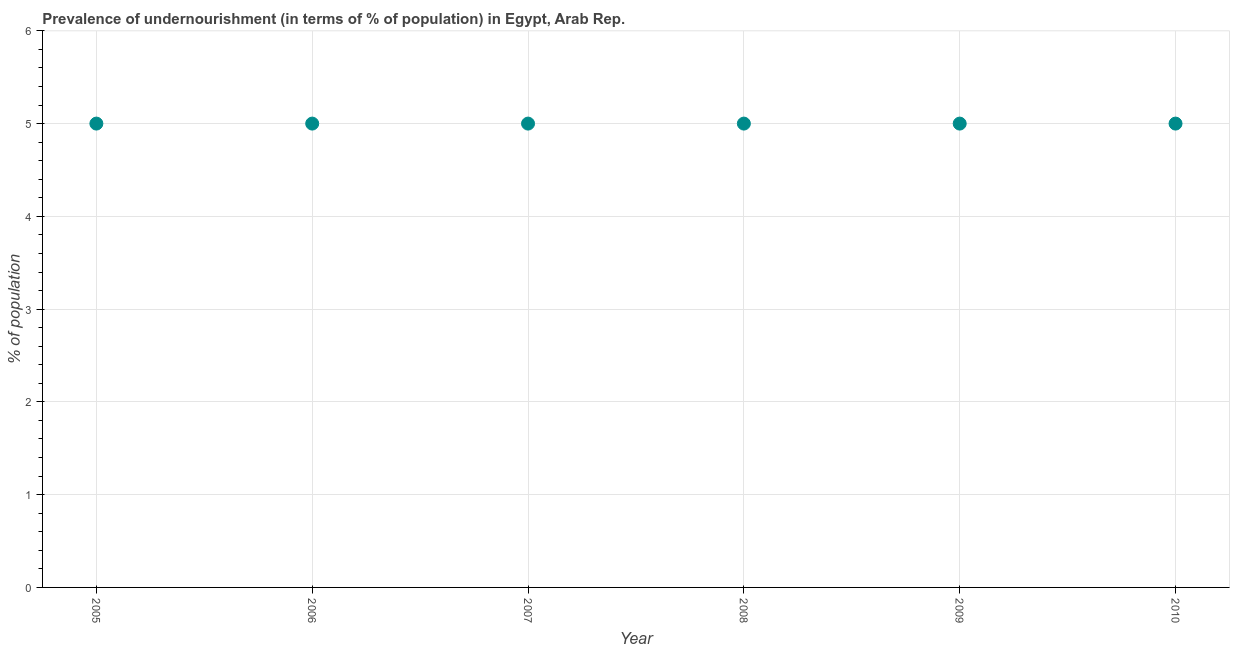What is the percentage of undernourished population in 2008?
Give a very brief answer. 5. Across all years, what is the maximum percentage of undernourished population?
Offer a terse response. 5. Across all years, what is the minimum percentage of undernourished population?
Keep it short and to the point. 5. In which year was the percentage of undernourished population maximum?
Offer a terse response. 2005. In which year was the percentage of undernourished population minimum?
Provide a short and direct response. 2005. What is the sum of the percentage of undernourished population?
Your answer should be compact. 30. What is the difference between the percentage of undernourished population in 2006 and 2008?
Your answer should be compact. 0. Do a majority of the years between 2006 and 2007 (inclusive) have percentage of undernourished population greater than 0.2 %?
Your response must be concise. Yes. What is the ratio of the percentage of undernourished population in 2006 to that in 2007?
Provide a succinct answer. 1. Is the sum of the percentage of undernourished population in 2005 and 2009 greater than the maximum percentage of undernourished population across all years?
Your response must be concise. Yes. What is the difference between the highest and the lowest percentage of undernourished population?
Offer a very short reply. 0. Does the percentage of undernourished population monotonically increase over the years?
Offer a very short reply. No. What is the difference between two consecutive major ticks on the Y-axis?
Ensure brevity in your answer.  1. Are the values on the major ticks of Y-axis written in scientific E-notation?
Ensure brevity in your answer.  No. What is the title of the graph?
Offer a very short reply. Prevalence of undernourishment (in terms of % of population) in Egypt, Arab Rep. What is the label or title of the Y-axis?
Give a very brief answer. % of population. What is the % of population in 2006?
Your response must be concise. 5. What is the % of population in 2007?
Your answer should be very brief. 5. What is the difference between the % of population in 2005 and 2008?
Offer a very short reply. 0. What is the difference between the % of population in 2005 and 2009?
Give a very brief answer. 0. What is the difference between the % of population in 2005 and 2010?
Your answer should be compact. 0. What is the difference between the % of population in 2008 and 2009?
Provide a succinct answer. 0. What is the ratio of the % of population in 2005 to that in 2008?
Offer a very short reply. 1. What is the ratio of the % of population in 2005 to that in 2010?
Your response must be concise. 1. What is the ratio of the % of population in 2006 to that in 2007?
Your answer should be very brief. 1. What is the ratio of the % of population in 2006 to that in 2008?
Provide a succinct answer. 1. What is the ratio of the % of population in 2007 to that in 2008?
Keep it short and to the point. 1. What is the ratio of the % of population in 2007 to that in 2009?
Make the answer very short. 1. What is the ratio of the % of population in 2008 to that in 2009?
Ensure brevity in your answer.  1. What is the ratio of the % of population in 2008 to that in 2010?
Provide a short and direct response. 1. What is the ratio of the % of population in 2009 to that in 2010?
Your answer should be compact. 1. 